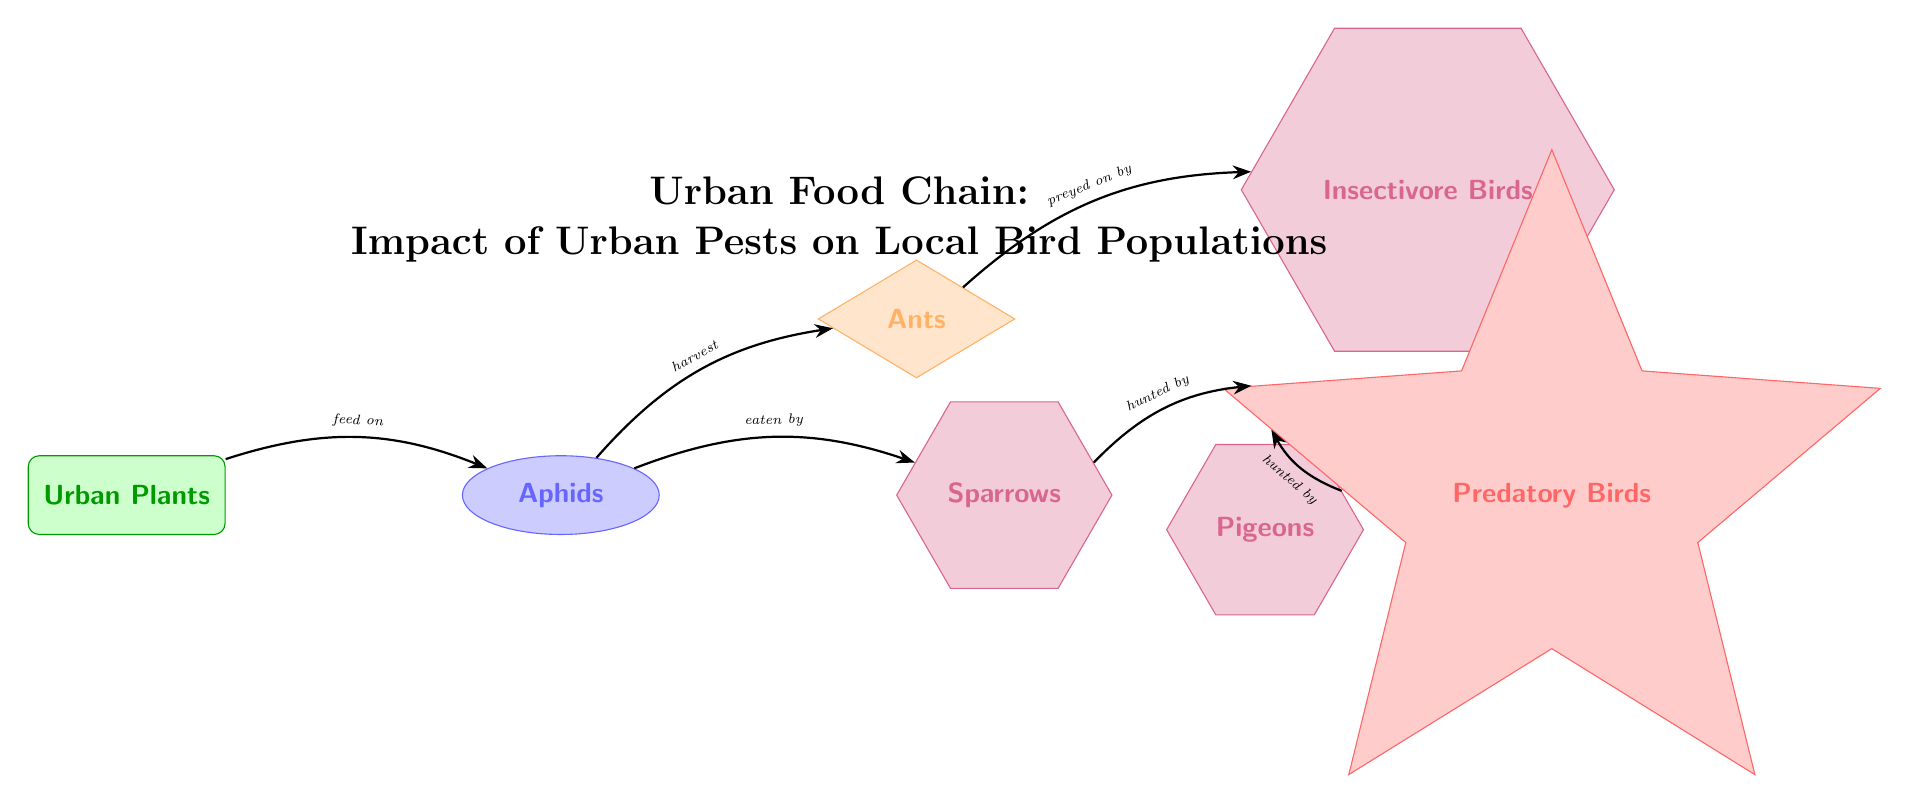What is the producer in this food chain? The diagram identifies "Urban Plants" as the producer at the leftmost node. Producers are organisms that create their own food through photosynthesis.
Answer: Urban Plants How many secondary consumers are present in the diagram? There is one secondary consumer, "Ants," which is positioned above the primary consumer "Aphids." Secondary consumers feed on primary consumers.
Answer: 1 Which consumer is hunted by the predatory birds? The diagram shows that both "Sparrows" and "Pigeons" are hunted by the "Predatory Birds," indicating the connections to the apex predator.
Answer: Sparrows and Pigeons What do aphids feed on? According to the diagram, aphids feed on "Urban Plants," as indicated by the directed edge from "Urban Plants" to "Aphids."
Answer: Urban Plants Which trophic level does the "Insectivore Birds" represent? "Insectivore Birds" in the diagram are classified as tertiary consumers as they prey upon the secondary consumer "Ants." Tertiary consumers occupy the third level in this chain.
Answer: Tertiary consumer How many total nodes are present in the food chain? By counting each distinct node in the diagram, there are seven nodes: Urban Plants, Aphids, Ants, Pigeons, Sparrows, Insectivore Birds, and Predatory Birds.
Answer: 7 What relationship exists between ants and insectivore birds? The diagram demonstrates that ants are preyed on by insectivore birds, which indicates a predator-prey relationship between these two consumers.
Answer: Preyed on by Which organism is at the top of the food chain? The "Predatory Birds" are positioned at the highest level in the diagram, representing the apex predator that has no natural enemies in this food chain.
Answer: Predatory Birds 